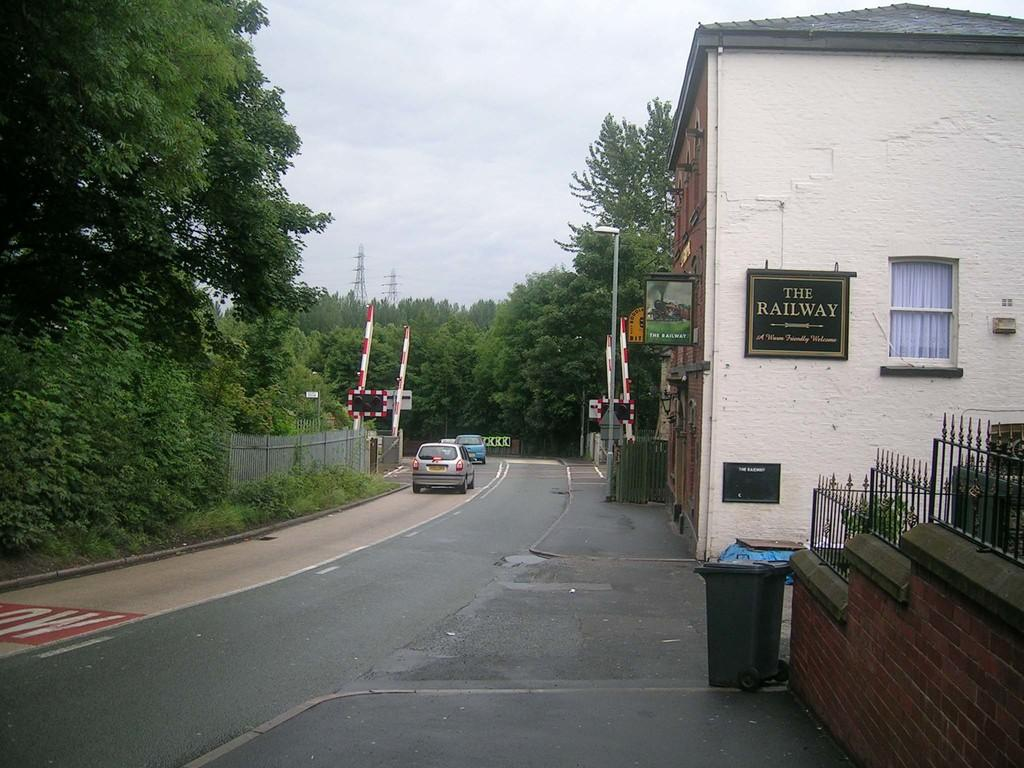<image>
Provide a brief description of the given image. A white building has a plaque on the side that reads "The Railway" 